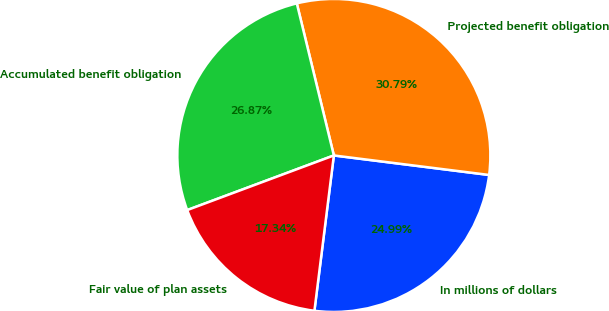Convert chart to OTSL. <chart><loc_0><loc_0><loc_500><loc_500><pie_chart><fcel>In millions of dollars<fcel>Projected benefit obligation<fcel>Accumulated benefit obligation<fcel>Fair value of plan assets<nl><fcel>24.99%<fcel>30.79%<fcel>26.87%<fcel>17.34%<nl></chart> 